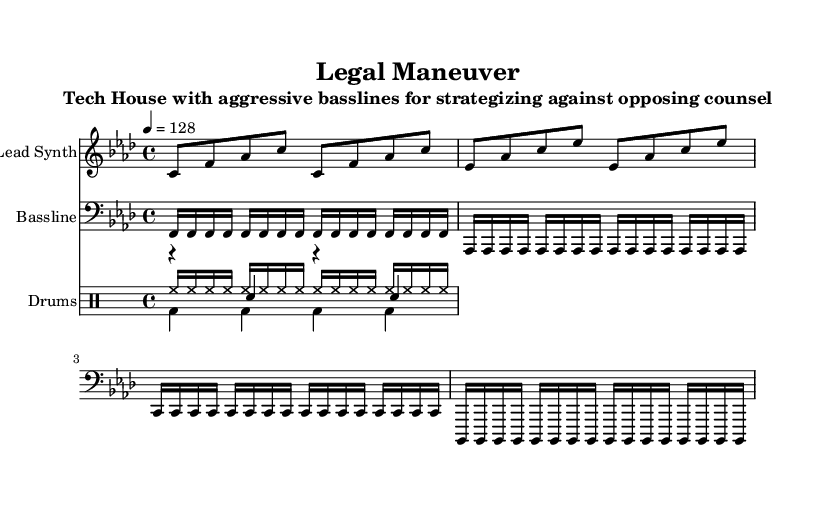What is the key signature of this music? The key signature indicated at the beginning of the staff is F minor, which contains four flats.
Answer: F minor What is the time signature of this music? The time signature is displayed at the beginning of the score, which shows a denominator of 4, indicating a 4/4 measure.
Answer: 4/4 What is the tempo marking for this piece? The tempo marking is given as 128 beats per minute (indicated with a quarter note = 128).
Answer: 128 How many measures are in the bassline? The bassline consists of four repetitions of four-note phrases, totaling 16 measures (4 phrases x 4 measures each).
Answer: 16 What is the primary rhythmic element used in the hi-hat? The hi-hat uses sixteenth notes, indicated by the notation within the drum staff, showing typical rhythmic patterns for house music.
Answer: Sixteenth notes Which instrument plays the aggressive bassline? The bassline is notated in the staff with the clef indicating it is played by a bass instrument.
Answer: Bass What kind of synthesizer pattern is used for the lead? The lead synth pattern consists of eighth notes, creating a syncopated rhythm across two measures.
Answer: Eighth notes 